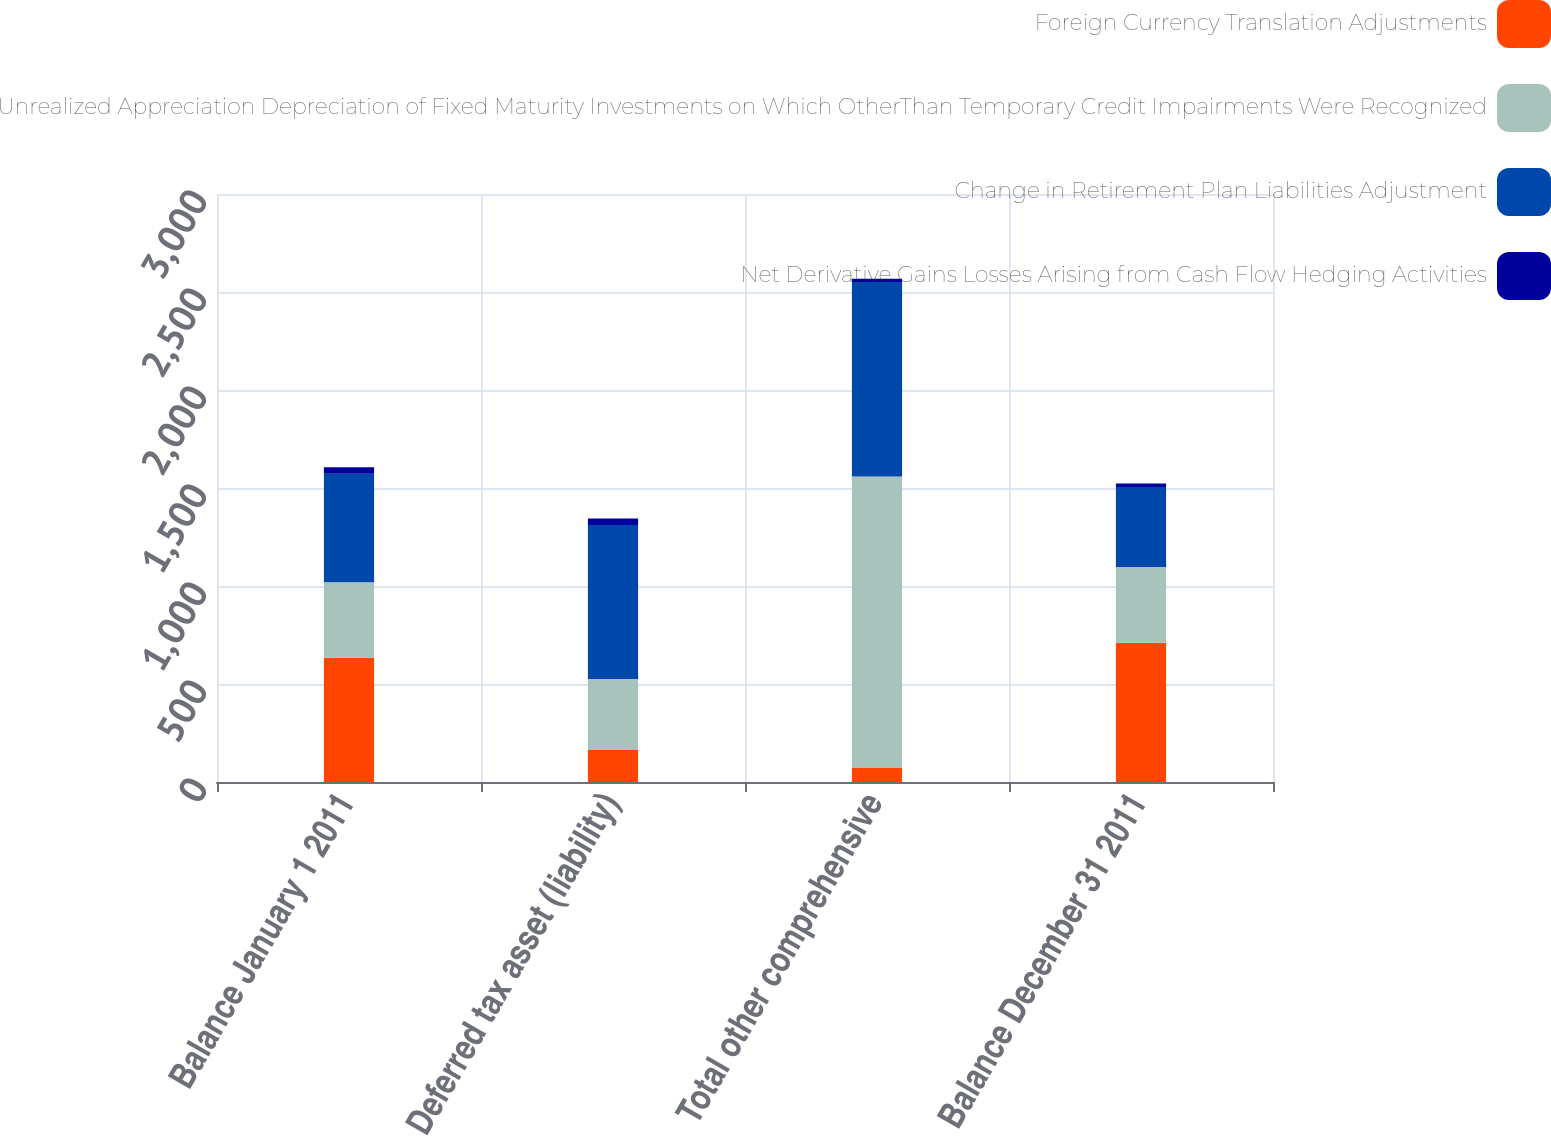Convert chart. <chart><loc_0><loc_0><loc_500><loc_500><stacked_bar_chart><ecel><fcel>Balance January 1 2011<fcel>Deferred tax asset (liability)<fcel>Total other comprehensive<fcel>Balance December 31 2011<nl><fcel>Foreign Currency Translation Adjustments<fcel>634<fcel>163<fcel>74<fcel>711<nl><fcel>Unrealized Appreciation Depreciation of Fixed Maturity Investments on Which OtherThan Temporary Credit Impairments Were Recognized<fcel>385.5<fcel>362<fcel>1485<fcel>385.5<nl><fcel>Change in Retirement Plan Liabilities Adjustment<fcel>553<fcel>786<fcel>992<fcel>409<nl><fcel>Net Derivative Gains Losses Arising from Cash Flow Hedging Activities<fcel>34<fcel>34<fcel>17<fcel>17<nl></chart> 